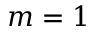<formula> <loc_0><loc_0><loc_500><loc_500>m = 1</formula> 